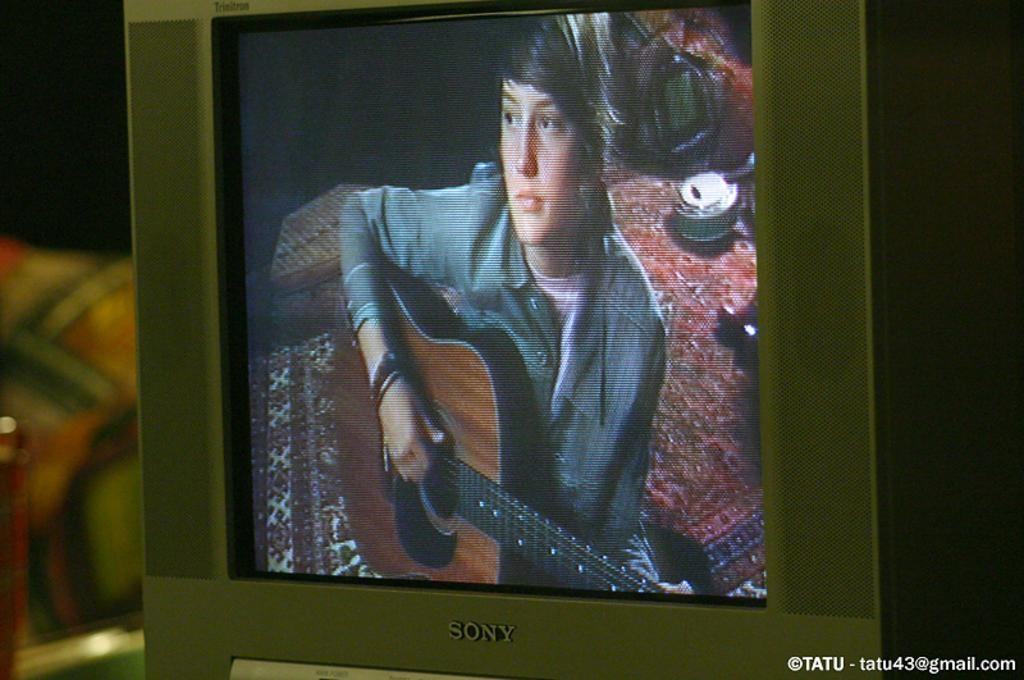<image>
Give a short and clear explanation of the subsequent image. A TV that says Sony on the front is showing a boy playing the guitar. 